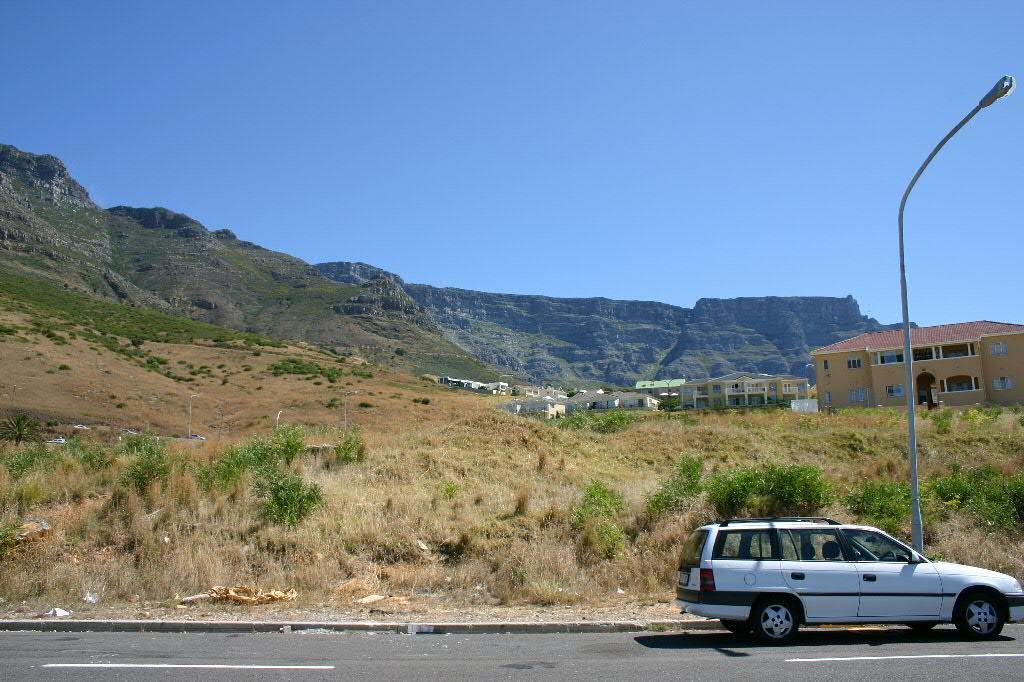Could you give a brief overview of what you see in this image? In this image I can see the road, a white colored vehicle on the road, few trees, a pole, few buildings and a mountain. In the background I can see the sky. 